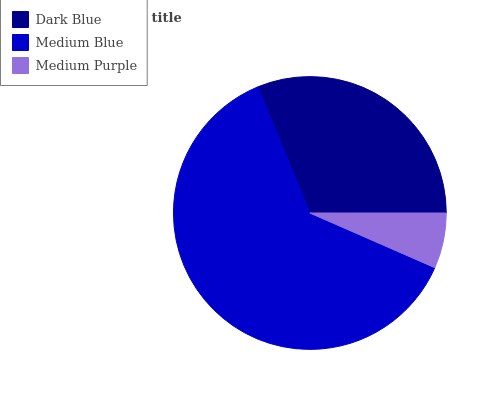Is Medium Purple the minimum?
Answer yes or no. Yes. Is Medium Blue the maximum?
Answer yes or no. Yes. Is Medium Blue the minimum?
Answer yes or no. No. Is Medium Purple the maximum?
Answer yes or no. No. Is Medium Blue greater than Medium Purple?
Answer yes or no. Yes. Is Medium Purple less than Medium Blue?
Answer yes or no. Yes. Is Medium Purple greater than Medium Blue?
Answer yes or no. No. Is Medium Blue less than Medium Purple?
Answer yes or no. No. Is Dark Blue the high median?
Answer yes or no. Yes. Is Dark Blue the low median?
Answer yes or no. Yes. Is Medium Purple the high median?
Answer yes or no. No. Is Medium Purple the low median?
Answer yes or no. No. 